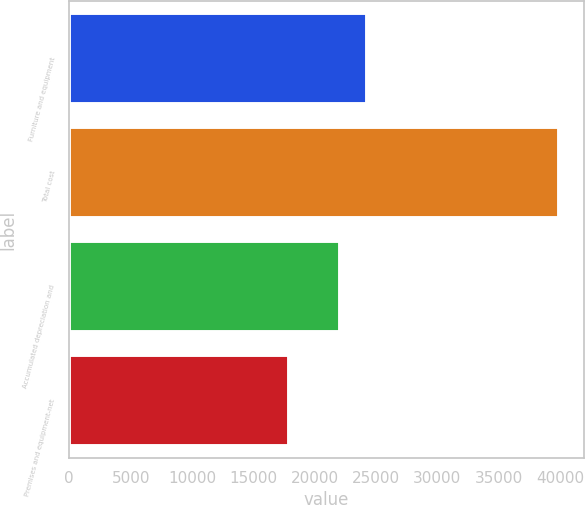<chart> <loc_0><loc_0><loc_500><loc_500><bar_chart><fcel>Furniture and equipment<fcel>Total cost<fcel>Accumulated depreciation and<fcel>Premises and equipment-net<nl><fcel>24246.2<fcel>39928<fcel>22042<fcel>17886<nl></chart> 